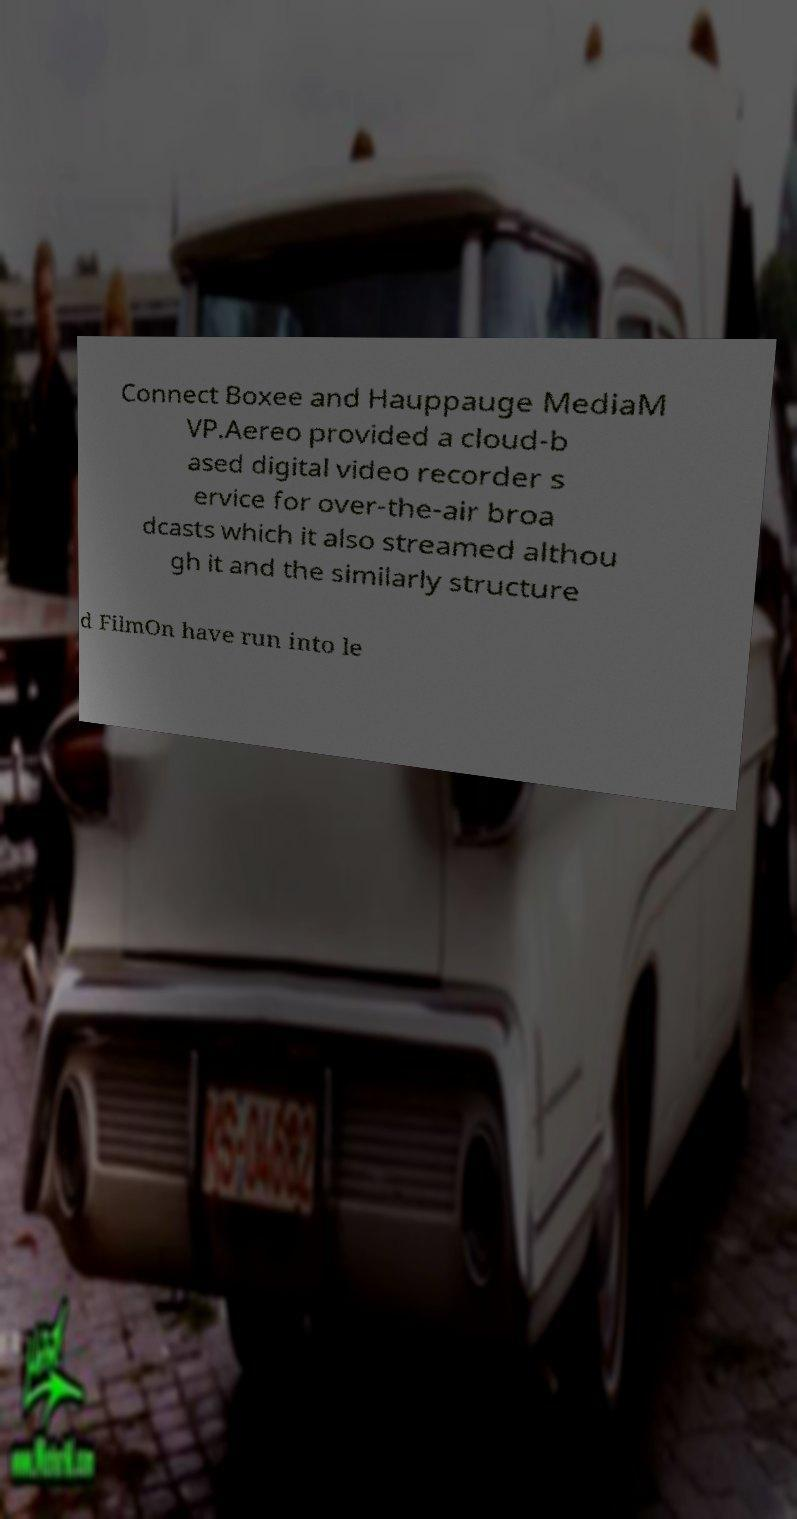Please read and relay the text visible in this image. What does it say? Connect Boxee and Hauppauge MediaM VP.Aereo provided a cloud-b ased digital video recorder s ervice for over-the-air broa dcasts which it also streamed althou gh it and the similarly structure d FilmOn have run into le 